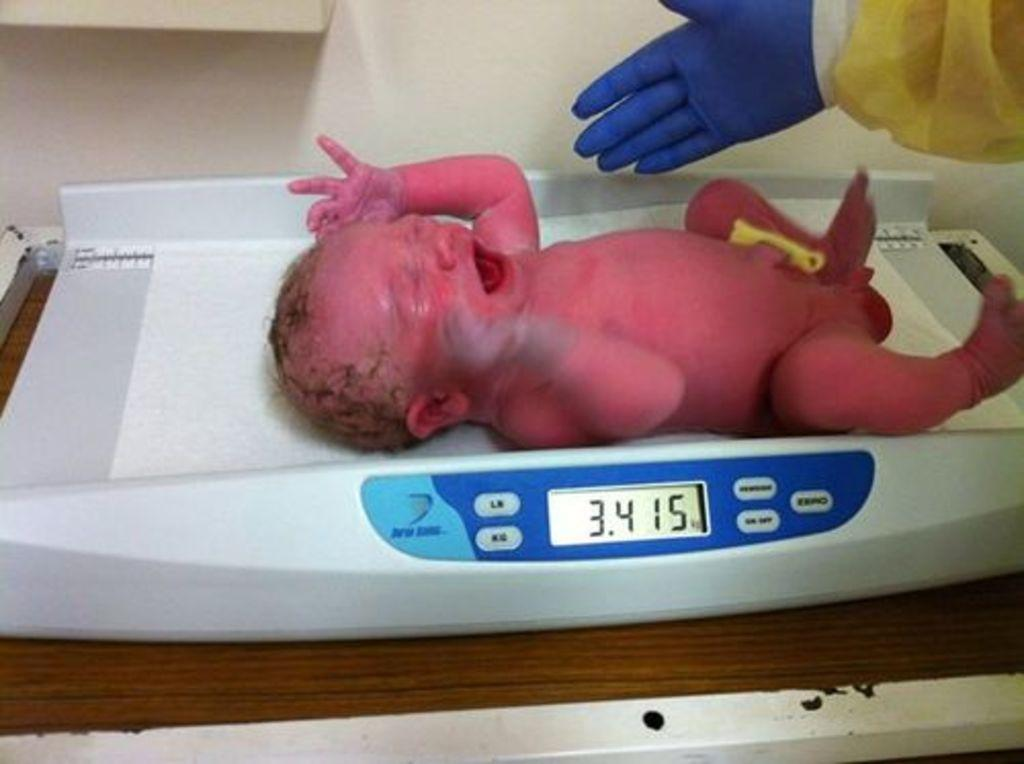What is the main subject of the image? There is a child in the image. Can you describe any other elements in the image? There is a human hand wearing gloves in the image. What type of pin is the child using to whistle in the image? There is no pin or whistle present in the image. How many fingers can be seen on the child's hand in the image? The image does not show the child's hand, only the human hand wearing gloves. 